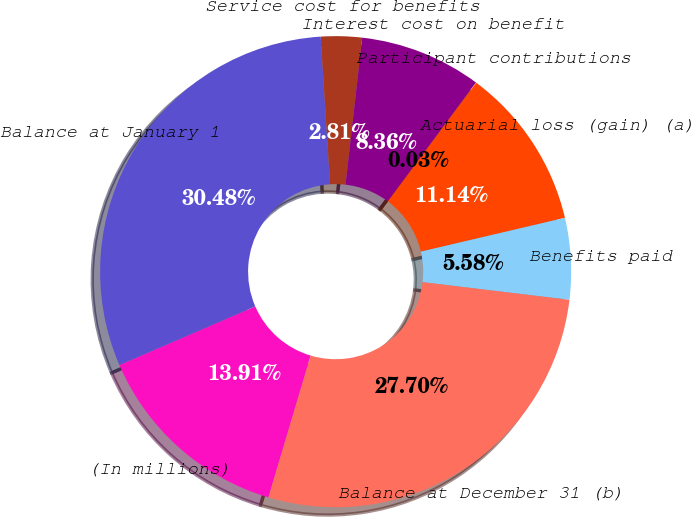<chart> <loc_0><loc_0><loc_500><loc_500><pie_chart><fcel>(In millions)<fcel>Balance at January 1<fcel>Service cost for benefits<fcel>Interest cost on benefit<fcel>Participant contributions<fcel>Actuarial loss (gain) (a)<fcel>Benefits paid<fcel>Balance at December 31 (b)<nl><fcel>13.91%<fcel>30.48%<fcel>2.81%<fcel>8.36%<fcel>0.03%<fcel>11.14%<fcel>5.58%<fcel>27.7%<nl></chart> 